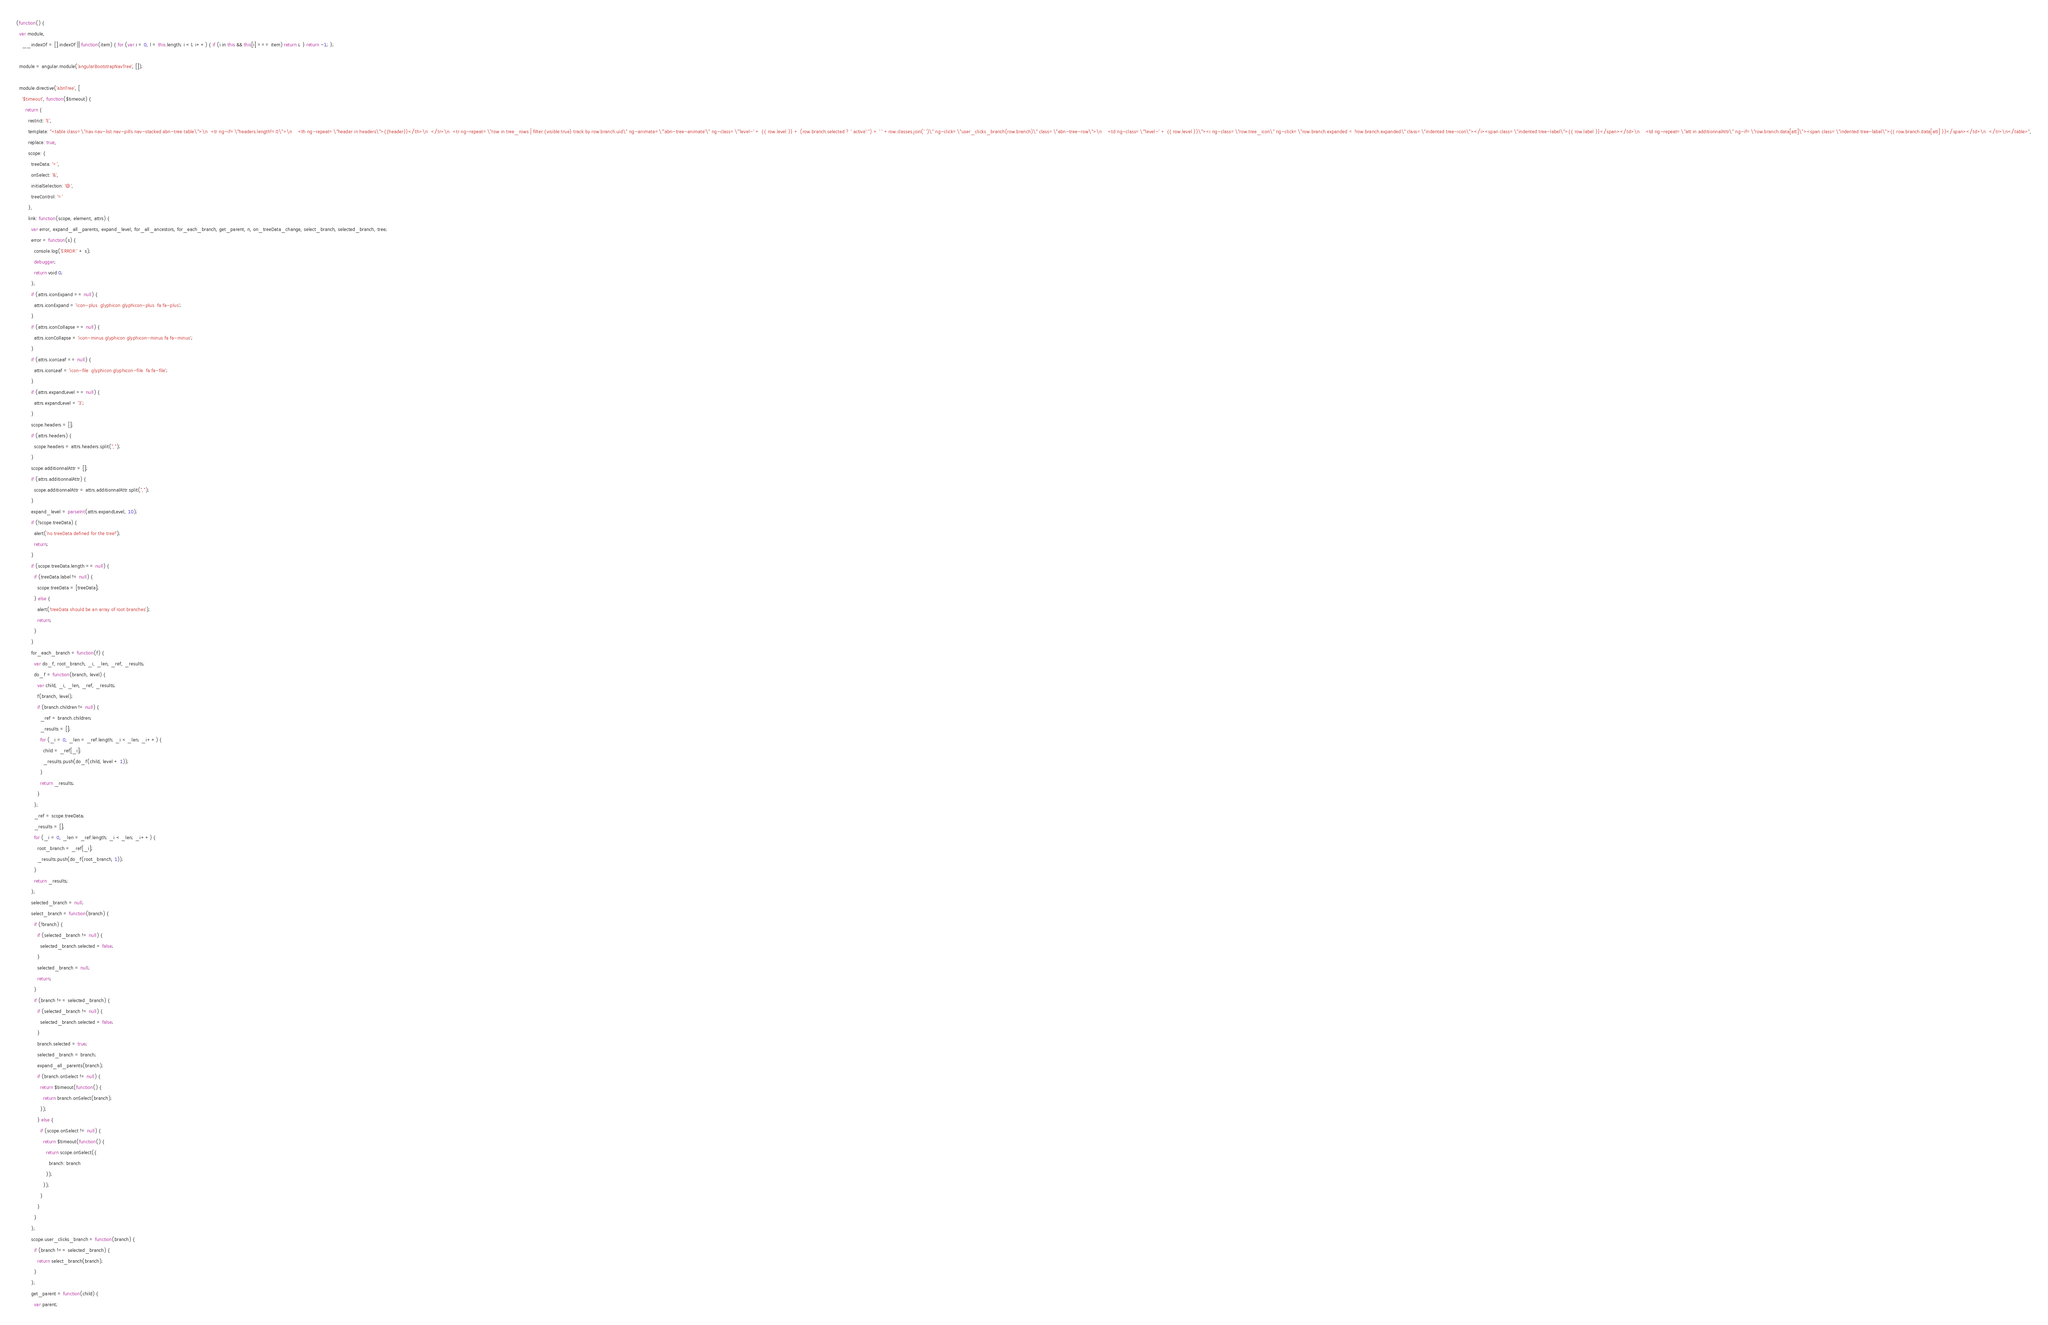<code> <loc_0><loc_0><loc_500><loc_500><_JavaScript_>(function() {
  var module,
    __indexOf = [].indexOf || function(item) { for (var i = 0, l = this.length; i < l; i++) { if (i in this && this[i] === item) return i; } return -1; };

  module = angular.module('angularBootstrapNavTree', []);

  module.directive('abnTree', [
    '$timeout', function($timeout) {
      return {
        restrict: 'E',
        template: "<table class=\"nav nav-list nav-pills nav-stacked abn-tree table\">\n  <tr ng-if=\"headers.length!=0\">\n    <th ng-repeat=\"header in headers\">{{header}}</th>\n  </tr>\n  <tr ng-repeat=\"row in tree_rows | filter:{visible:true} track by row.branch.uid\" ng-animate=\"'abn-tree-animate'\" ng-class=\"'level-' + {{ row.level }} + (row.branch.selected ? ' active':'') + ' ' +row.classes.join(' ')\" ng-click=\"user_clicks_branch(row.branch)\" class=\"abn-tree-row\">\n    <td ng-class=\"'level-' + {{ row.level }}\"><i ng-class=\"row.tree_icon\" ng-click=\"row.branch.expanded = !row.branch.expanded\" class=\"indented tree-icon\"></i><span class=\"indented tree-label\">{{ row.label }}</span></td>\n    <td ng-repeat=\"att in additionnalAttr\" ng-if=\"row.branch.data[att]\"><span class=\"indented tree-label\">{{ row.branch.data[att] }}</span></td>\n  </tr>\n</table>",
        replace: true,
        scope: {
          treeData: '=',
          onSelect: '&',
          initialSelection: '@',
          treeControl: '='
        },
        link: function(scope, element, attrs) {
          var error, expand_all_parents, expand_level, for_all_ancestors, for_each_branch, get_parent, n, on_treeData_change, select_branch, selected_branch, tree;
          error = function(s) {
            console.log('ERROR:' + s);
            debugger;
            return void 0;
          };
          if (attrs.iconExpand == null) {
            attrs.iconExpand = 'icon-plus  glyphicon glyphicon-plus  fa fa-plus';
          }
          if (attrs.iconCollapse == null) {
            attrs.iconCollapse = 'icon-minus glyphicon glyphicon-minus fa fa-minus';
          }
          if (attrs.iconLeaf == null) {
            attrs.iconLeaf = 'icon-file  glyphicon glyphicon-file  fa fa-file';
          }
          if (attrs.expandLevel == null) {
            attrs.expandLevel = '3';
          }
          scope.headers = [];
          if (attrs.headers) {
            scope.headers = attrs.headers.split(",");
          }
          scope.additionnalAttr = [];
          if (attrs.additionnalAttr) {
            scope.additionnalAttr = attrs.additionnalAttr.split(",");
          }
          expand_level = parseInt(attrs.expandLevel, 10);
          if (!scope.treeData) {
            alert('no treeData defined for the tree!');
            return;
          }
          if (scope.treeData.length == null) {
            if (treeData.label != null) {
              scope.treeData = [treeData];
            } else {
              alert('treeData should be an array of root branches');
              return;
            }
          }
          for_each_branch = function(f) {
            var do_f, root_branch, _i, _len, _ref, _results;
            do_f = function(branch, level) {
              var child, _i, _len, _ref, _results;
              f(branch, level);
              if (branch.children != null) {
                _ref = branch.children;
                _results = [];
                for (_i = 0, _len = _ref.length; _i < _len; _i++) {
                  child = _ref[_i];
                  _results.push(do_f(child, level + 1));
                }
                return _results;
              }
            };
            _ref = scope.treeData;
            _results = [];
            for (_i = 0, _len = _ref.length; _i < _len; _i++) {
              root_branch = _ref[_i];
              _results.push(do_f(root_branch, 1));
            }
            return _results;
          };
          selected_branch = null;
          select_branch = function(branch) {
            if (!branch) {
              if (selected_branch != null) {
                selected_branch.selected = false;
              }
              selected_branch = null;
              return;
            }
            if (branch !== selected_branch) {
              if (selected_branch != null) {
                selected_branch.selected = false;
              }
              branch.selected = true;
              selected_branch = branch;
              expand_all_parents(branch);
              if (branch.onSelect != null) {
                return $timeout(function() {
                  return branch.onSelect(branch);
                });
              } else {
                if (scope.onSelect != null) {
                  return $timeout(function() {
                    return scope.onSelect({
                      branch: branch
                    });
                  });
                }
              }
            }
          };
          scope.user_clicks_branch = function(branch) {
            if (branch !== selected_branch) {
              return select_branch(branch);
            }
          };
          get_parent = function(child) {
            var parent;</code> 